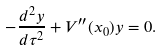<formula> <loc_0><loc_0><loc_500><loc_500>- \frac { d ^ { 2 } y } { d \tau ^ { 2 } } + V ^ { \prime \prime } ( x _ { 0 } ) y = 0 .</formula> 